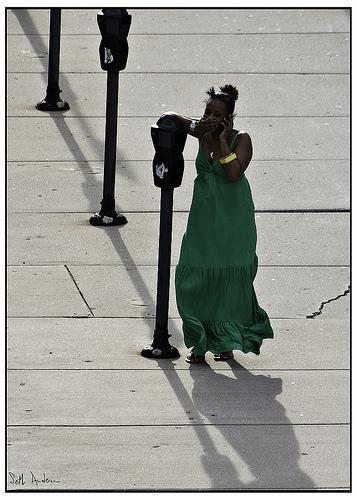How many white labels?
Give a very brief answer. 2. How many parking meters?
Give a very brief answer. 3. 